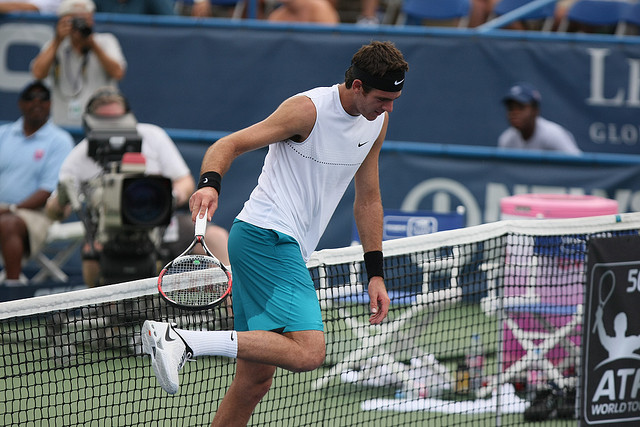<image>Are they playing doubles? I am not sure if they are playing doubles. Are they playing doubles? I don't know if they are playing doubles. It is not clear from the information given. 